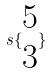<formula> <loc_0><loc_0><loc_500><loc_500>s \{ \begin{matrix} 5 \\ 3 \end{matrix} \}</formula> 